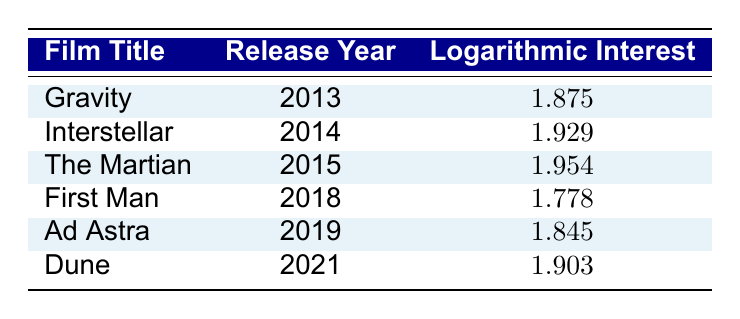What is the logarithmic interest value for "The Martian"? The table lists "The Martian" under the film title column, and the corresponding logarithmic interest is found in its row, which is 1.954.
Answer: 1.954 Which film had the highest logarithmic interest? By comparing the logarithmic interest values in the table, "The Martian" has the highest value of 1.954.
Answer: The Martian What is the difference between the logarithmic interest of "Gravity" and "First Man"? The logarithmic interest for "Gravity" is 1.875 and for "First Man" it is 1.778. To find the difference, subtract 1.778 from 1.875, which equals 0.097.
Answer: 0.097 True or False: "Ad Astra" has a higher logarithmic interest than "Dune." The logarithmic interest for "Ad Astra" is 1.845 and for "Dune" it is 1.903, meaning "Ad Astra" does not have a higher value.
Answer: False What is the average logarithmic interest of the films released in 2014 and 2019? The films released in 2014 and 2019 are "Interstellar" and "Ad Astra," with logarithmic interests of 1.929 and 1.845, respectively. Adding them gives 1.929 + 1.845 = 3.774. There are 2 films, so dividing by 2 results in an average of 1.887.
Answer: 1.887 Which film released in 2018 had the lowest logarithmic interest among the films listed? The film released in 2018 is "First Man," and looking at the table, its logarithmic interest is 1.778. Since it is the only film from that year listed, it is indeed the lowest for that year.
Answer: First Man How many films have a logarithmic interest greater than 1.9? By scanning through the table, the films "Interstellar," "The Martian," and "Dune" have logarithmic interests of 1.929, 1.954, and 1.903 respectively. That totals to three films with a value greater than 1.9.
Answer: 3 What is the total logarithmic interest of all films listed in the table? To find the total, we add all the logarithmic interest values: 1.875 + 1.929 + 1.954 + 1.778 + 1.845 + 1.903 = 11.384.
Answer: 11.384 Did "Gravity" have a higher public interest index than "First Man"? The public interest index for "Gravity" is 75 while for "First Man" it is 60. Since 75 is greater than 60, "Gravity" indeed had a higher public interest index.
Answer: Yes 